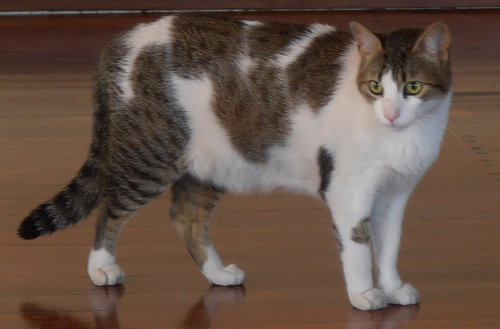<image>
Is there a cat on the floor? Yes. Looking at the image, I can see the cat is positioned on top of the floor, with the floor providing support. Is the table under the cat? Yes. The table is positioned underneath the cat, with the cat above it in the vertical space. 